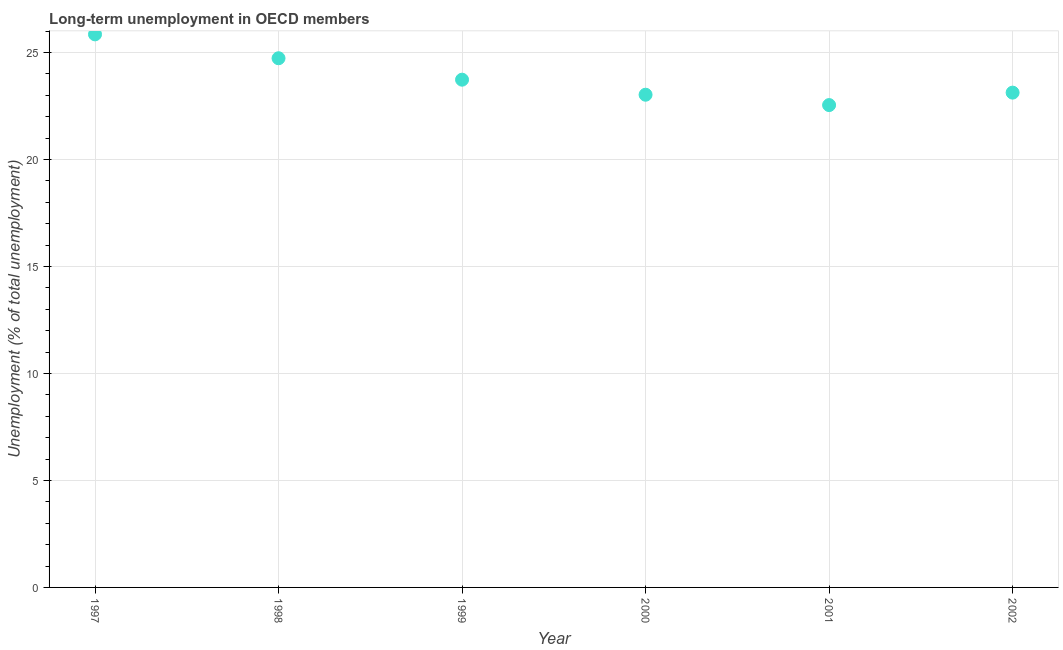What is the long-term unemployment in 2002?
Offer a very short reply. 23.12. Across all years, what is the maximum long-term unemployment?
Make the answer very short. 25.85. Across all years, what is the minimum long-term unemployment?
Give a very brief answer. 22.54. What is the sum of the long-term unemployment?
Give a very brief answer. 143. What is the difference between the long-term unemployment in 1997 and 1999?
Ensure brevity in your answer.  2.12. What is the average long-term unemployment per year?
Give a very brief answer. 23.83. What is the median long-term unemployment?
Offer a terse response. 23.43. In how many years, is the long-term unemployment greater than 8 %?
Your answer should be very brief. 6. Do a majority of the years between 2001 and 2000 (inclusive) have long-term unemployment greater than 11 %?
Ensure brevity in your answer.  No. What is the ratio of the long-term unemployment in 1998 to that in 2002?
Provide a succinct answer. 1.07. Is the long-term unemployment in 1998 less than that in 2000?
Your answer should be compact. No. Is the difference between the long-term unemployment in 1999 and 2001 greater than the difference between any two years?
Offer a terse response. No. What is the difference between the highest and the second highest long-term unemployment?
Give a very brief answer. 1.12. Is the sum of the long-term unemployment in 1999 and 2002 greater than the maximum long-term unemployment across all years?
Offer a terse response. Yes. What is the difference between the highest and the lowest long-term unemployment?
Make the answer very short. 3.3. How many years are there in the graph?
Ensure brevity in your answer.  6. Does the graph contain grids?
Ensure brevity in your answer.  Yes. What is the title of the graph?
Your answer should be compact. Long-term unemployment in OECD members. What is the label or title of the X-axis?
Provide a succinct answer. Year. What is the label or title of the Y-axis?
Provide a succinct answer. Unemployment (% of total unemployment). What is the Unemployment (% of total unemployment) in 1997?
Your answer should be compact. 25.85. What is the Unemployment (% of total unemployment) in 1998?
Your response must be concise. 24.73. What is the Unemployment (% of total unemployment) in 1999?
Ensure brevity in your answer.  23.73. What is the Unemployment (% of total unemployment) in 2000?
Offer a terse response. 23.03. What is the Unemployment (% of total unemployment) in 2001?
Ensure brevity in your answer.  22.54. What is the Unemployment (% of total unemployment) in 2002?
Make the answer very short. 23.12. What is the difference between the Unemployment (% of total unemployment) in 1997 and 1998?
Offer a very short reply. 1.12. What is the difference between the Unemployment (% of total unemployment) in 1997 and 1999?
Make the answer very short. 2.12. What is the difference between the Unemployment (% of total unemployment) in 1997 and 2000?
Offer a terse response. 2.82. What is the difference between the Unemployment (% of total unemployment) in 1997 and 2001?
Keep it short and to the point. 3.3. What is the difference between the Unemployment (% of total unemployment) in 1997 and 2002?
Make the answer very short. 2.72. What is the difference between the Unemployment (% of total unemployment) in 1998 and 1999?
Offer a terse response. 1. What is the difference between the Unemployment (% of total unemployment) in 1998 and 2000?
Offer a very short reply. 1.7. What is the difference between the Unemployment (% of total unemployment) in 1998 and 2001?
Your response must be concise. 2.19. What is the difference between the Unemployment (% of total unemployment) in 1998 and 2002?
Provide a succinct answer. 1.61. What is the difference between the Unemployment (% of total unemployment) in 1999 and 2000?
Ensure brevity in your answer.  0.7. What is the difference between the Unemployment (% of total unemployment) in 1999 and 2001?
Your response must be concise. 1.19. What is the difference between the Unemployment (% of total unemployment) in 1999 and 2002?
Provide a succinct answer. 0.61. What is the difference between the Unemployment (% of total unemployment) in 2000 and 2001?
Your answer should be very brief. 0.48. What is the difference between the Unemployment (% of total unemployment) in 2000 and 2002?
Keep it short and to the point. -0.1. What is the difference between the Unemployment (% of total unemployment) in 2001 and 2002?
Provide a short and direct response. -0.58. What is the ratio of the Unemployment (% of total unemployment) in 1997 to that in 1998?
Provide a succinct answer. 1.04. What is the ratio of the Unemployment (% of total unemployment) in 1997 to that in 1999?
Offer a very short reply. 1.09. What is the ratio of the Unemployment (% of total unemployment) in 1997 to that in 2000?
Provide a succinct answer. 1.12. What is the ratio of the Unemployment (% of total unemployment) in 1997 to that in 2001?
Your answer should be very brief. 1.15. What is the ratio of the Unemployment (% of total unemployment) in 1997 to that in 2002?
Provide a short and direct response. 1.12. What is the ratio of the Unemployment (% of total unemployment) in 1998 to that in 1999?
Provide a succinct answer. 1.04. What is the ratio of the Unemployment (% of total unemployment) in 1998 to that in 2000?
Keep it short and to the point. 1.07. What is the ratio of the Unemployment (% of total unemployment) in 1998 to that in 2001?
Your answer should be very brief. 1.1. What is the ratio of the Unemployment (% of total unemployment) in 1998 to that in 2002?
Keep it short and to the point. 1.07. What is the ratio of the Unemployment (% of total unemployment) in 1999 to that in 2000?
Keep it short and to the point. 1.03. What is the ratio of the Unemployment (% of total unemployment) in 1999 to that in 2001?
Your answer should be very brief. 1.05. What is the ratio of the Unemployment (% of total unemployment) in 1999 to that in 2002?
Your answer should be very brief. 1.03. What is the ratio of the Unemployment (% of total unemployment) in 2000 to that in 2001?
Make the answer very short. 1.02. 